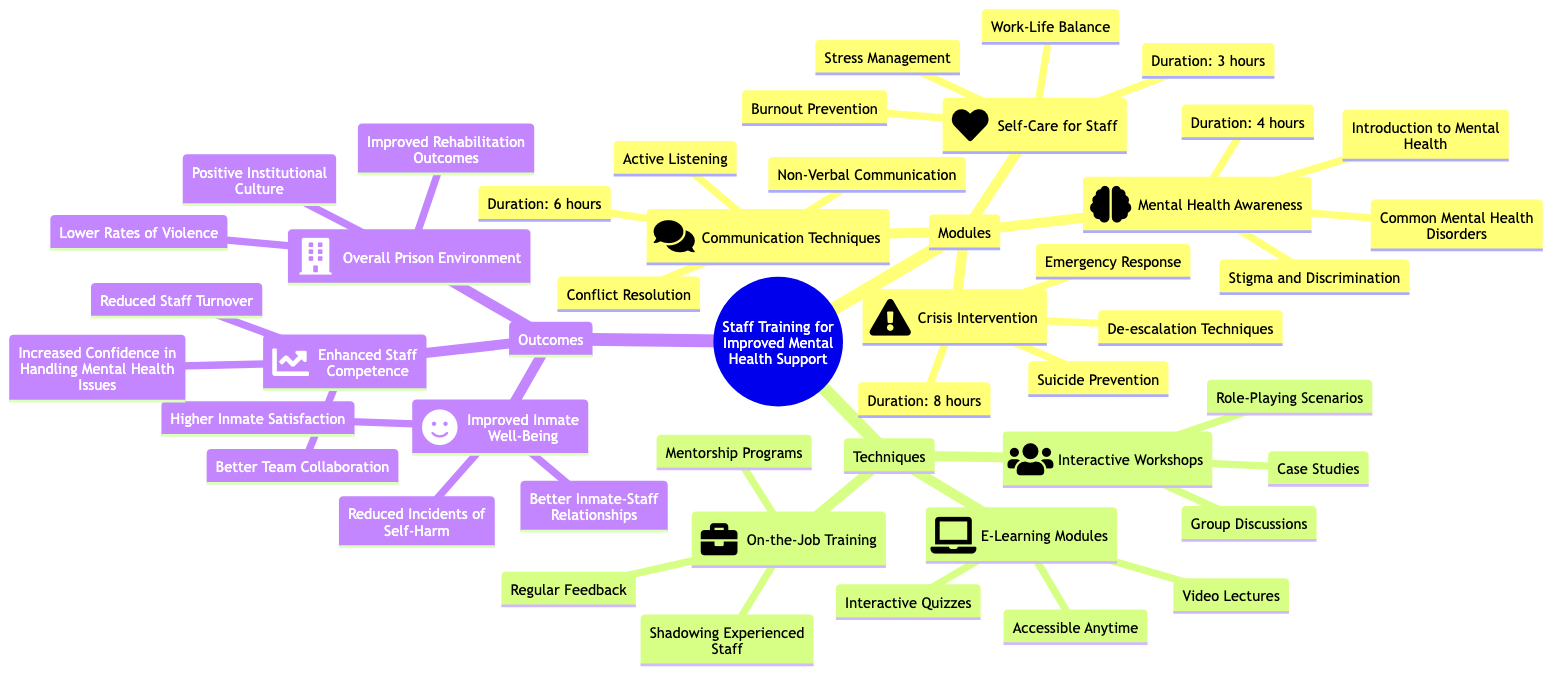What is the duration of the 'Self-Care for Staff' module? The duration is specified directly under the 'Self-Care for Staff' module in the diagram, which shows "Duration: 3 hours."
Answer: 3 hours How many topics are covered in the 'Crisis Intervention' module? The 'Crisis Intervention' module lists three topics: "De-escalation Techniques," "Suicide Prevention," and "Emergency Response." This count is based on the three items listed under that module.
Answer: 3 What method is included in the 'Interactive Workshops' technique? The method "Role-Playing Scenarios" is one of the methods listed under 'Interactive Workshops' in the diagram.
Answer: Role-Playing Scenarios What is the main outcome indicated for 'Overall Prison Environment'? The first indicator listed under 'Overall Prison Environment' is "Lower Rates of Violence," which captures the essence of the outcome's focus.
Answer: Lower Rates of Violence Which training technique offers interactive quizzes? The training technique that provides "Interactive Quizzes" is specified under the 'E-Learning Modules.' This feature is part of the methods described within that category.
Answer: E-Learning Modules How many modules focus on direct mental health support (not including self-care)? There are three modules that focus directly on mental health support: "Mental Health Awareness," "Communication Techniques," and "Crisis Intervention." Thus, we count these modules to obtain the answer.
Answer: 3 What is one indicator of 'Enhanced Staff Competence'? The indicator mentioned for 'Enhanced Staff Competence' is "Increased Confidence in Handling Mental Health Issues," which is one direct indicator listed under that category.
Answer: Increased Confidence in Handling Mental Health Issues What duration is assigned to the 'Communication Techniques' module? The diagram specifies the duration for the 'Communication Techniques' module as "Duration: 6 hours," which is directly noted below that module.
Answer: 6 hours 